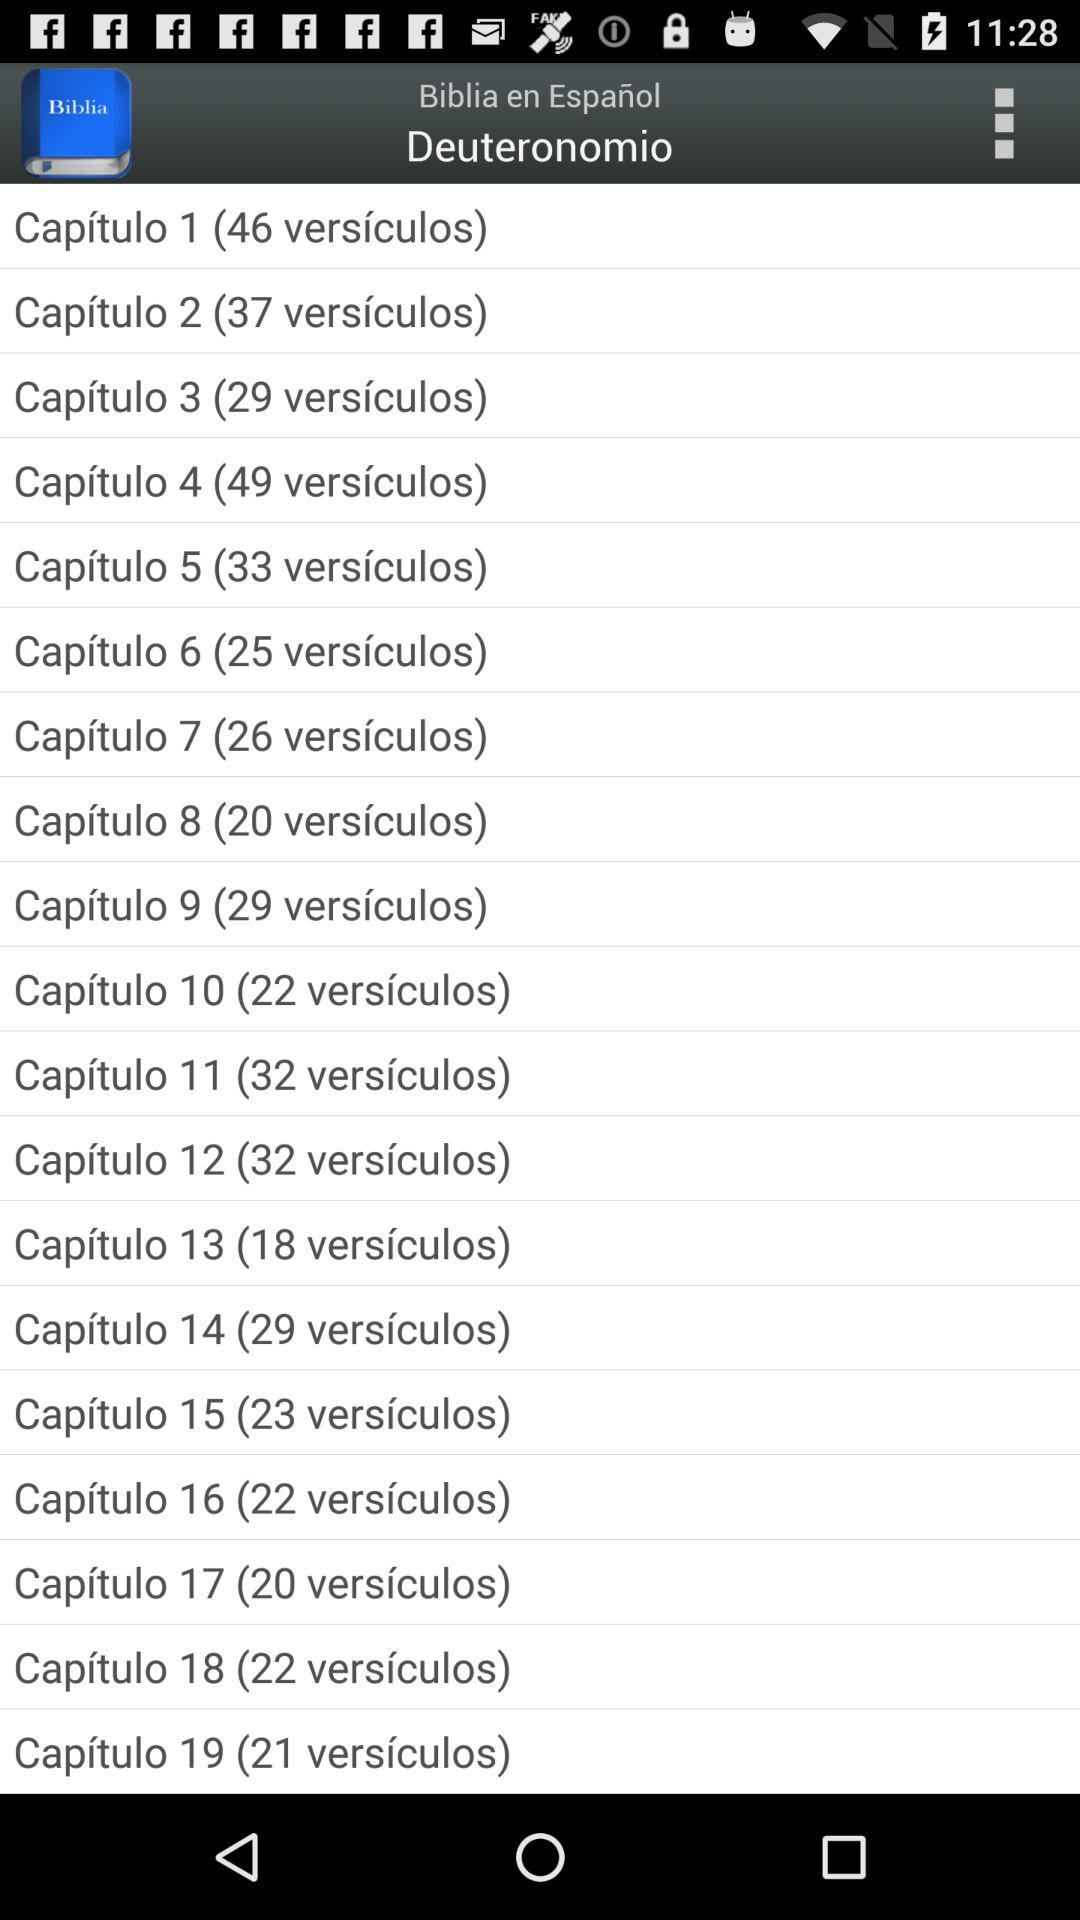How many chapters are there in Deuteronomy?
Answer the question using a single word or phrase. 19 